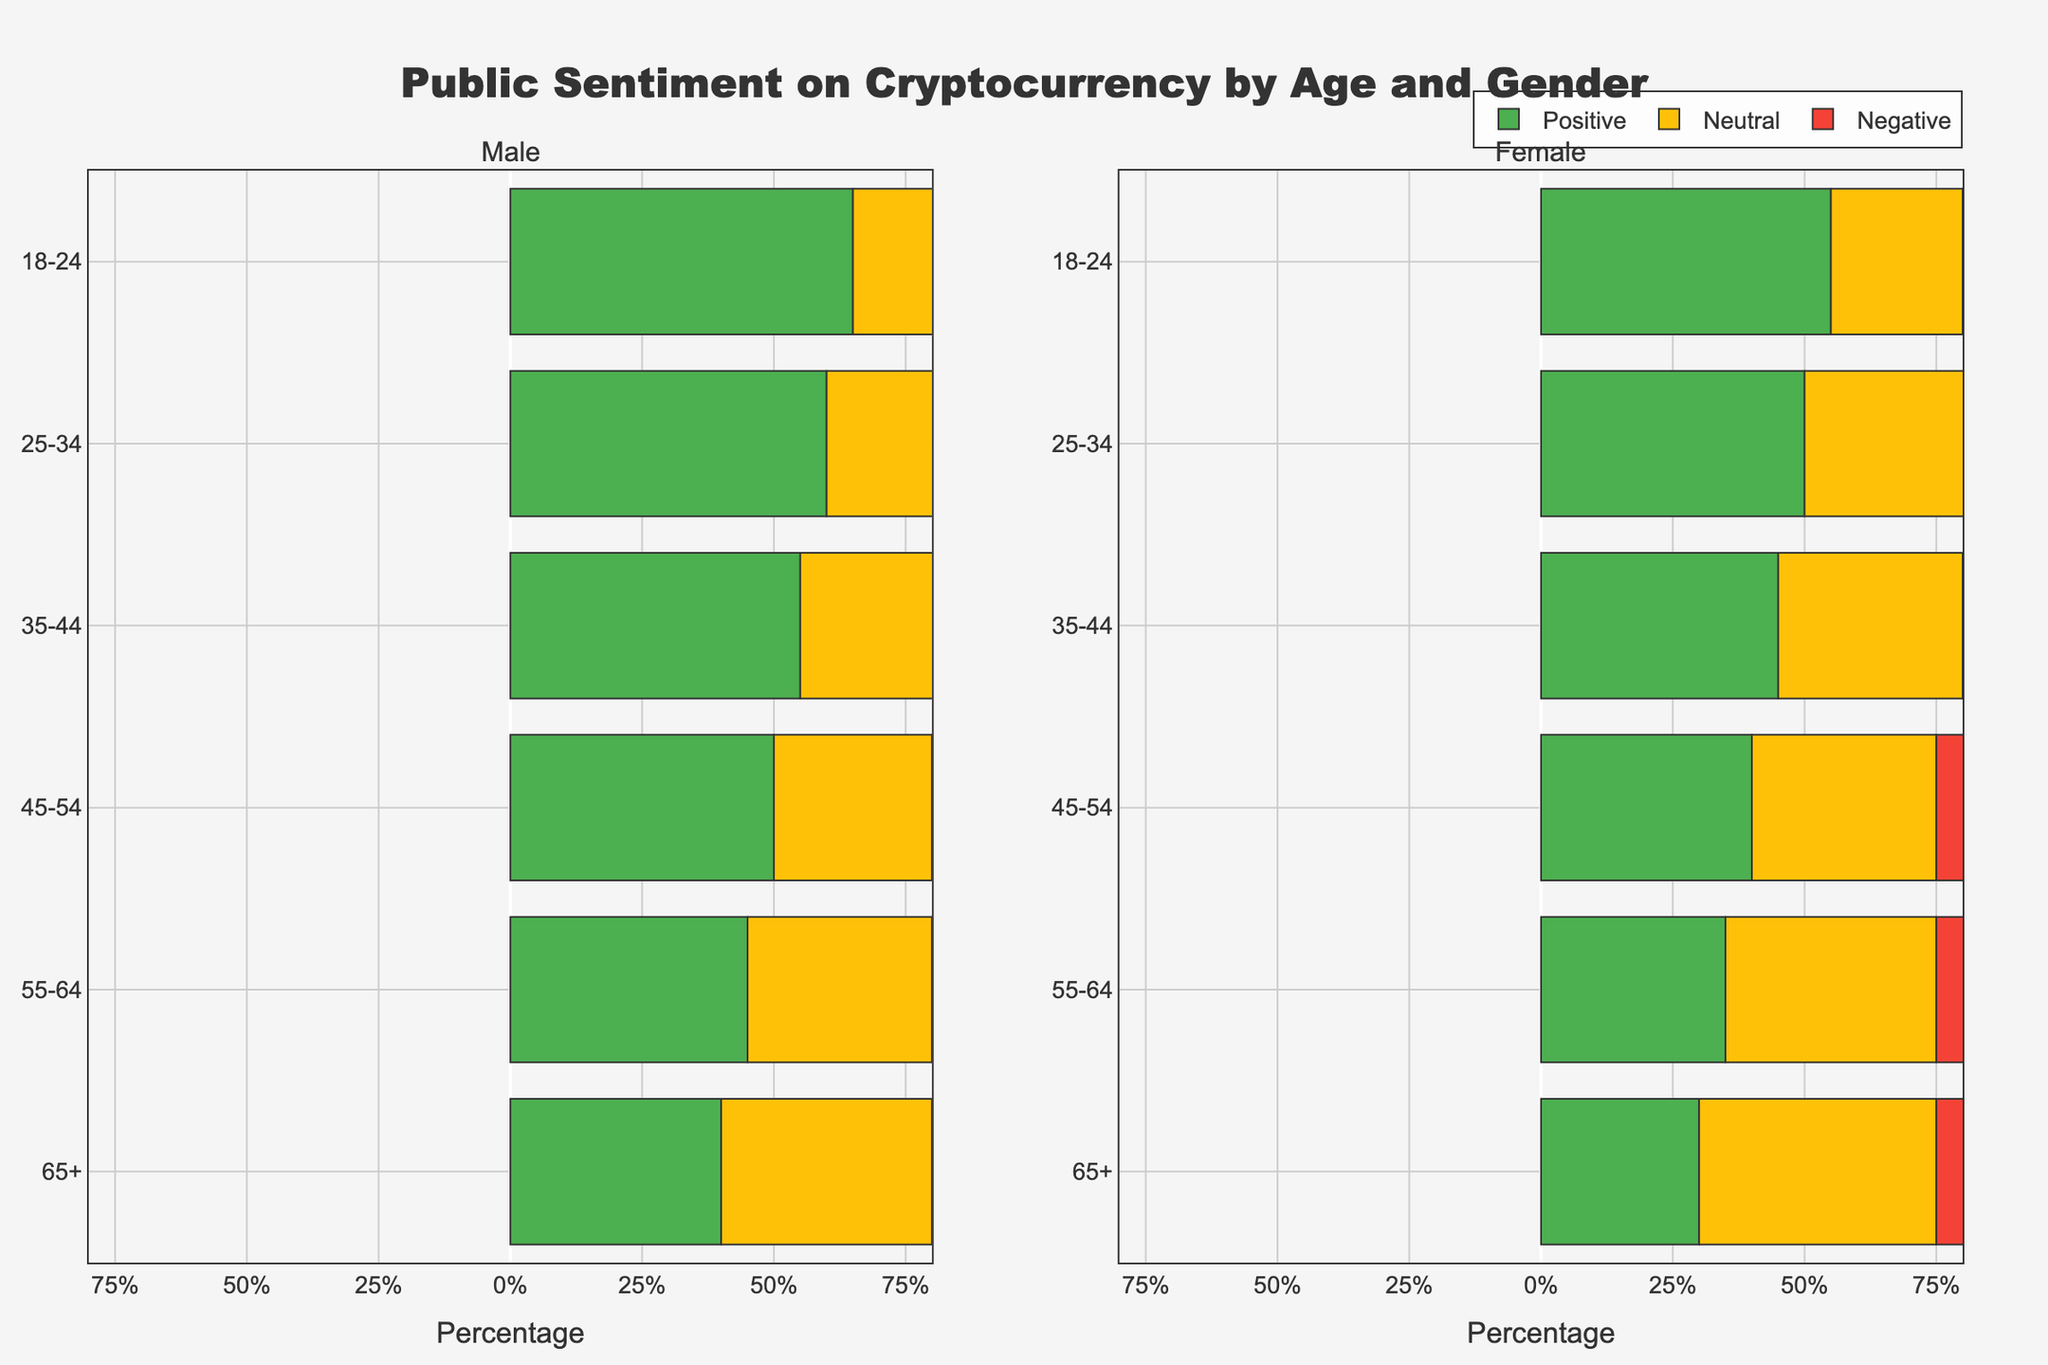Which age group has the highest positive sentiment among males? Look at the bars in the male subplot. The age group 18-24 has the tallest green bar, indicating the highest positive sentiment.
Answer: 18-24 What is the difference in positive sentiment between 18-24 males and 18-24 females? Find the height of the green bars for both groups. 18-24 males have 65% positive sentiment, and 18-24 females have 55%. Subtract 55 from 65 to get the difference.
Answer: 10% Which gender has a higher negative sentiment in the 55-64 age group? Compare the red bars for the 55-64 age group. Females have a longer red bar (25%) than males (20%).
Answer: Female In which age group is the neutral sentiment equal for both genders? Check the yellow bars across age groups for both genders. The age group 65+ has matching yellow bars at 40%.
Answer: 65+ Add the neutral and negative sentiment percentages for 45-54 males. What is the total? Look at the yellow and red bars for 45-54 males. The neutral sentiment is 30% and the negative sentiment is 20%. Adding them together gives 50%.
Answer: 50% Which age group shows the least positive sentiment across all age groups and genders? Compare the green bars for all subgroups. Females aged 65+ have the shortest green bar at 30%.
Answer: 65+, Female What is the average positive sentiment across all age groups for females? Add the green bars for all female age groups (55 + 50 + 45 + 40 + 35 + 30) and divide by the number of age groups (6). This results in (55 + 50 + 45 + 40 + 35 + 30) / 6 = 42.5%.
Answer: 42.5% Compare the sum of negative and neutral sentiments for females aged 25-34 to males of the same age group. Which is higher? For 25-34 females: neutral + negative = 35% + 15% = 50%. For 25-34 males: neutral + negative = 30% + 10% = 40%. Females have a higher combined sentiment.
Answer: Females Which age group has the most balanced sentiment (closest values for positive, neutral, and negative) for males? Look at where the green, yellow, and red bars are closest in length. Age group 65+ males have values of 40 (positive), 40 (neutral), and 20 (negative), which are relatively balanced.
Answer: 65+ What is the total neutral sentiment for both genders in the 35-44 age group? Sum the yellow bars for 35-44 males (30%) and 35-44 females (35%), resulting in 30% + 35% = 65%.
Answer: 65% 